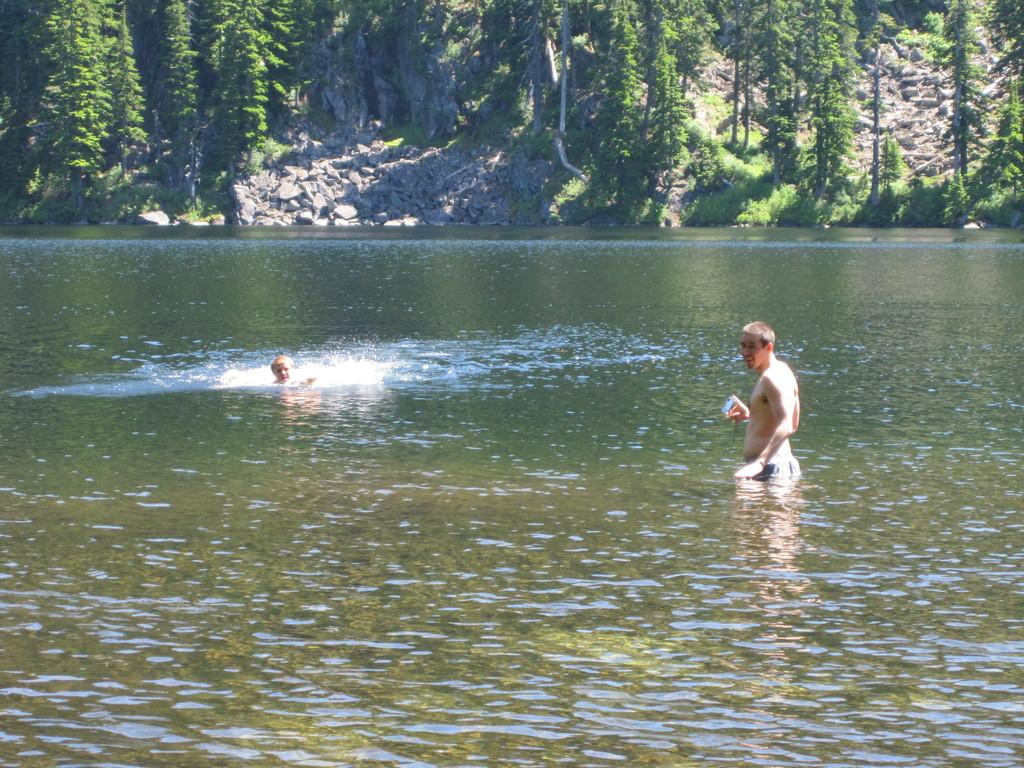How many people are in the water in the image? There are two persons in the water in the image. What else can be seen in the image besides the people in the water? Rocks and trees are visible in the image. What type of button can be seen on the tree in the image? There is no button present on the tree in the image. 